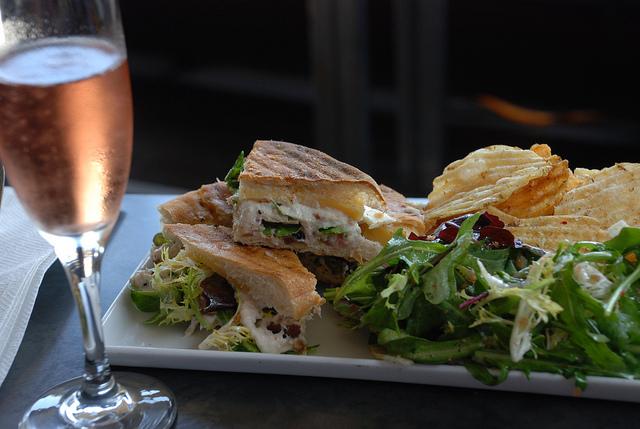Is the cup full?
Quick response, please. Yes. What is the person drinking?
Concise answer only. Wine. Is this a healthy lunch?
Be succinct. Yes. What color is the plate?
Write a very short answer. White. Is the glass empty?
Give a very brief answer. No. Does the glass have wine in it?
Give a very brief answer. Yes. 